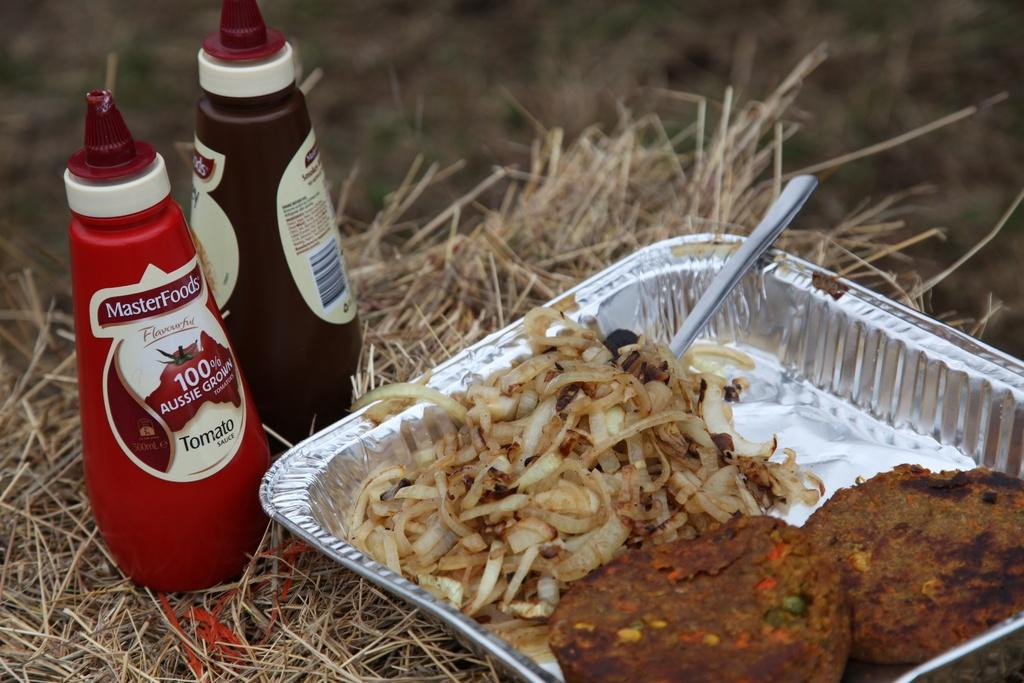<image>
Provide a brief description of the given image. A bottle of Masterfoods Tomato sauce is next to a bottle of smokey barbacue. 